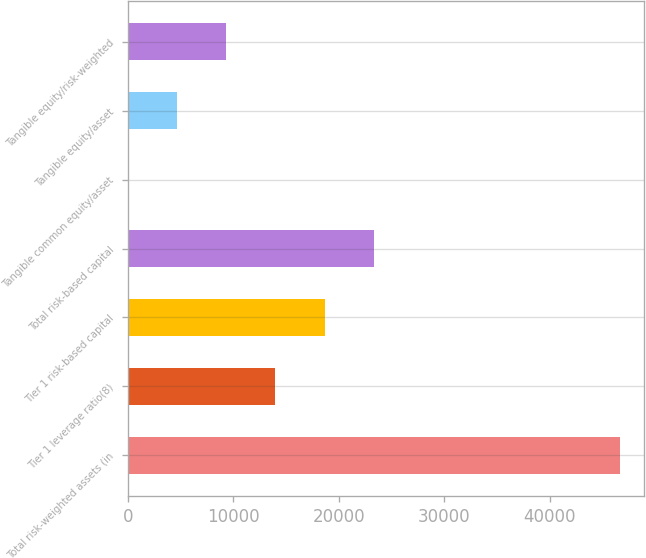<chart> <loc_0><loc_0><loc_500><loc_500><bar_chart><fcel>Total risk-weighted assets (in<fcel>Tier 1 leverage ratio(8)<fcel>Tier 1 risk-based capital<fcel>Total risk-based capital<fcel>Tangible common equity/asset<fcel>Tangible equity/asset<fcel>Tangible equity/risk-weighted<nl><fcel>46602<fcel>13984<fcel>18643.7<fcel>23303.4<fcel>4.81<fcel>4664.53<fcel>9324.25<nl></chart> 